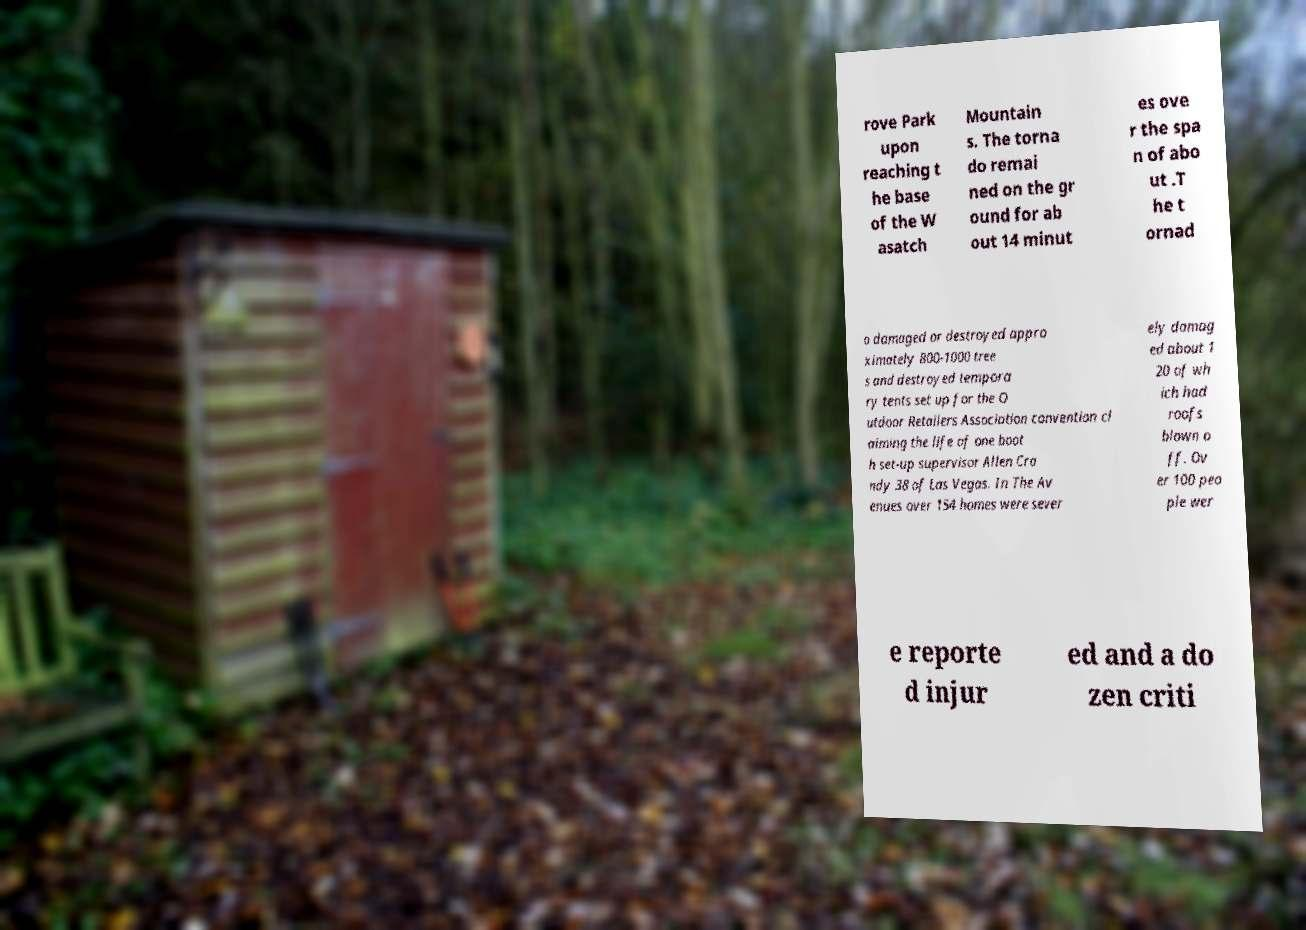There's text embedded in this image that I need extracted. Can you transcribe it verbatim? rove Park upon reaching t he base of the W asatch Mountain s. The torna do remai ned on the gr ound for ab out 14 minut es ove r the spa n of abo ut .T he t ornad o damaged or destroyed appro ximately 800-1000 tree s and destroyed tempora ry tents set up for the O utdoor Retailers Association convention cl aiming the life of one boot h set-up supervisor Allen Cra ndy 38 of Las Vegas. In The Av enues over 154 homes were sever ely damag ed about 1 20 of wh ich had roofs blown o ff. Ov er 100 peo ple wer e reporte d injur ed and a do zen criti 